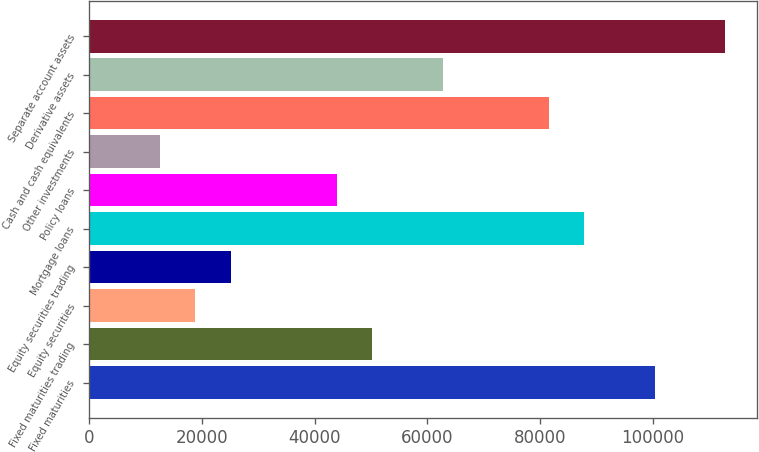Convert chart to OTSL. <chart><loc_0><loc_0><loc_500><loc_500><bar_chart><fcel>Fixed maturities<fcel>Fixed maturities trading<fcel>Equity securities<fcel>Equity securities trading<fcel>Mortgage loans<fcel>Policy loans<fcel>Other investments<fcel>Cash and cash equivalents<fcel>Derivative assets<fcel>Separate account assets<nl><fcel>100322<fcel>50210.6<fcel>18891<fcel>25154.9<fcel>87794.2<fcel>43946.7<fcel>12627.1<fcel>81530.3<fcel>62738.5<fcel>112850<nl></chart> 